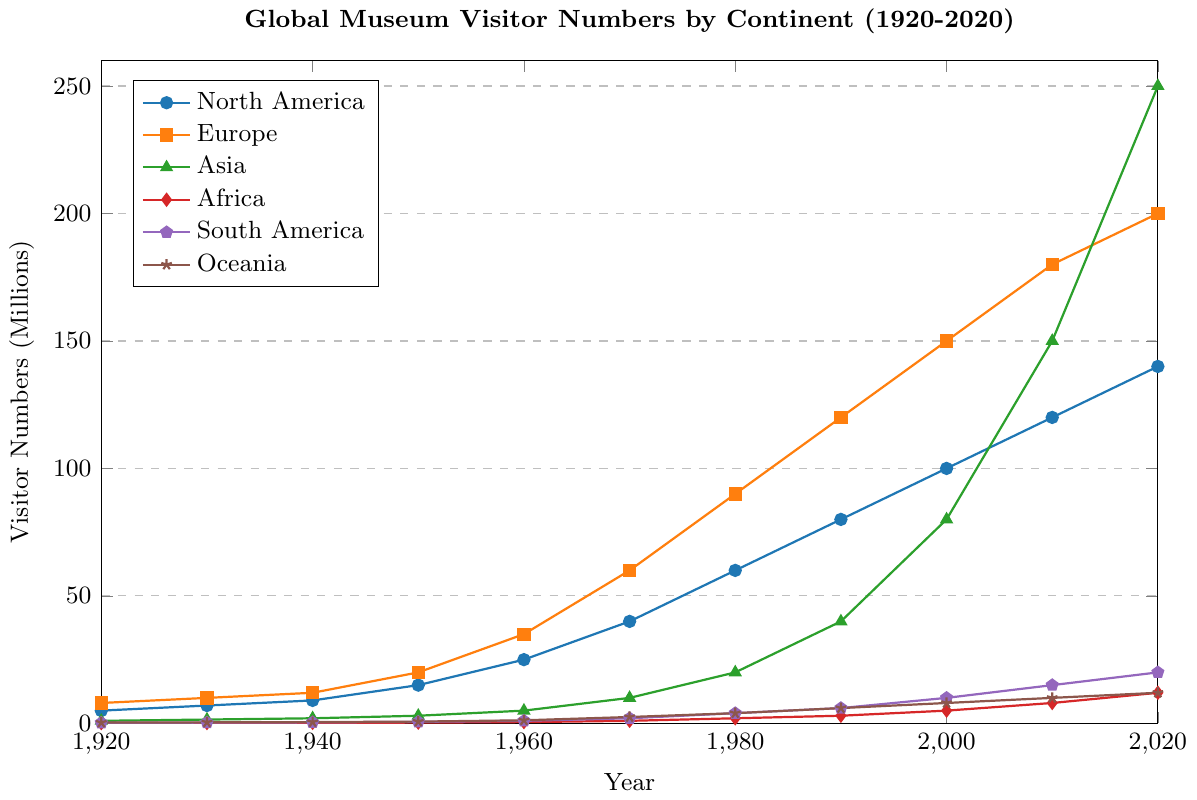What is the range of visitor numbers for Europe from 1920 to 2020? The range is calculated by subtracting the smallest value from the largest value. The smallest value for Europe is 8 million (in 1920), and the largest value is 200 million (in 2020). The range is thus 200 - 8.
Answer: 192 million Which continent saw the greatest increase in museum visitors between 1980 and 2020? To determine the greatest increase, subtract the 1980 value from the 2020 value for each continent. North America: 140 - 60 = 80 million; Europe: 200 - 90 = 110 million; Asia: 250 - 20 = 230 million; Africa: 12 - 2 = 10 million; South America: 20 - 4 = 16 million; Oceania: 12 - 4 = 8 million. Asia has the greatest increase.
Answer: Asia What is the combined number of museum visitors in 2020 for South America and Oceania? Add the visitor numbers for South America (20 million) and Oceania (12 million) for the year 2020. 20 + 12 = 32 million.
Answer: 32 million How many times more visitors did Asia have compared to Africa in 2020? Divide the number of visitors in Asia by the number of visitors in Africa for 2020. 250 million (Asia) / 12 million (Africa) = approximately 20.83 times.
Answer: Approximately 20.83 times Which continent had the highest number of museum visitors consistently from 1920 to 2020? Examine the visitor numbers for each year across the continents. Europe has the highest number of visitors each year, from 1920 to 2020.
Answer: Europe In which year did South America's museum visitor numbers reach 1 million? According to the figure, South America's visitor numbers were 1 million in the year 1960.
Answer: 1960 What was the average annual increase in museum visitors for Oceania between 1920 and 2020? To find the average annual increase, first, calculate the total increase over the period and then divide by the number of years. Increase from 1920 to 2020: 12 million - 0.3 million = 11.7 million. The period is 100 years. 11.7 / 100 = 0.117 million per year.
Answer: 0.117 million per year Between 1950 and 1970, which continent saw the most significant change in museum visitor numbers? Calculate the change for each continent between 1950 and 1970 by subtracting the numbers for 1950 from those of 1970. North America: 40 - 15 = 25 million; Europe: 60 - 20 = 40 million; Asia: 10 - 3 = 7 million; Africa: 1 - 0.3 = 0.7 million; South America: 2 - 0.6 = 1.4 million; Oceania: 2.5 - 0.7 = 1.8 million. Europe has the most significant change.
Answer: Europe Which continent had the lowest number of museum visitors in 1940, and what was that number? Examine the visitor numbers for 1940. Africa had the lowest number of museum visitors in 1940 with 0.2 million.
Answer: Africa, 0.2 million 